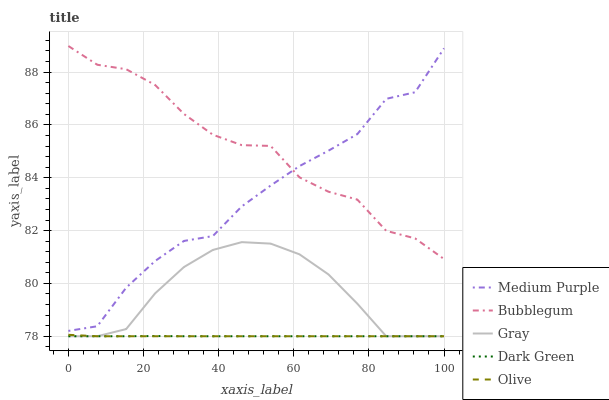Does Dark Green have the minimum area under the curve?
Answer yes or no. Yes. Does Bubblegum have the maximum area under the curve?
Answer yes or no. Yes. Does Gray have the minimum area under the curve?
Answer yes or no. No. Does Gray have the maximum area under the curve?
Answer yes or no. No. Is Dark Green the smoothest?
Answer yes or no. Yes. Is Medium Purple the roughest?
Answer yes or no. Yes. Is Gray the smoothest?
Answer yes or no. No. Is Gray the roughest?
Answer yes or no. No. Does Gray have the lowest value?
Answer yes or no. Yes. Does Bubblegum have the lowest value?
Answer yes or no. No. Does Bubblegum have the highest value?
Answer yes or no. Yes. Does Gray have the highest value?
Answer yes or no. No. Is Gray less than Bubblegum?
Answer yes or no. Yes. Is Medium Purple greater than Olive?
Answer yes or no. Yes. Does Dark Green intersect Olive?
Answer yes or no. Yes. Is Dark Green less than Olive?
Answer yes or no. No. Is Dark Green greater than Olive?
Answer yes or no. No. Does Gray intersect Bubblegum?
Answer yes or no. No. 